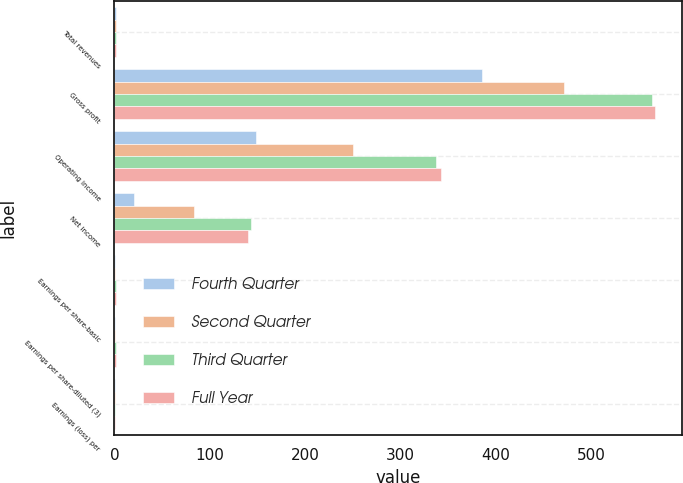Convert chart to OTSL. <chart><loc_0><loc_0><loc_500><loc_500><stacked_bar_chart><ecel><fcel>Total revenues<fcel>Gross profit<fcel>Operating income<fcel>Net income<fcel>Earnings per share-basic<fcel>Earnings per share-diluted (3)<fcel>Earnings (loss) per<nl><fcel>Fourth Quarter<fcel>1.42<fcel>385<fcel>149<fcel>21<fcel>0.22<fcel>0.19<fcel>0.17<nl><fcel>Second Quarter<fcel>1.42<fcel>471<fcel>250<fcel>83<fcel>0.89<fcel>0.78<fcel>0.63<nl><fcel>Third Quarter<fcel>1.42<fcel>564<fcel>337<fcel>143<fcel>1.53<fcel>1.35<fcel>0.7<nl><fcel>Full Year<fcel>1.42<fcel>567<fcel>342<fcel>140<fcel>1.49<fcel>1.31<fcel>0.4<nl></chart> 